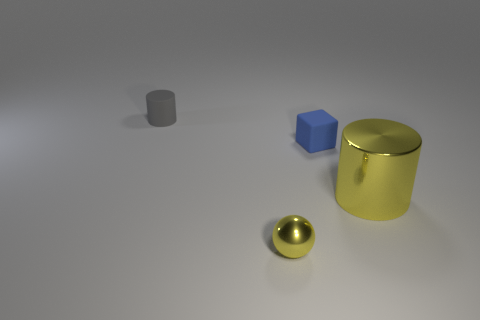How many things are either rubber things or rubber objects that are behind the tiny matte block?
Give a very brief answer. 2. There is a matte thing to the left of the block; is its shape the same as the metallic object behind the sphere?
Make the answer very short. Yes. Are there any other things that are the same color as the tiny shiny sphere?
Offer a terse response. Yes. What shape is the tiny blue thing that is made of the same material as the tiny gray cylinder?
Provide a succinct answer. Cube. What is the thing that is both to the left of the large yellow cylinder and in front of the small blue cube made of?
Keep it short and to the point. Metal. Is there any other thing that is the same size as the gray cylinder?
Provide a succinct answer. Yes. Is the small cylinder the same color as the small block?
Make the answer very short. No. The small object that is the same color as the metal cylinder is what shape?
Offer a terse response. Sphere. What number of small metallic things have the same shape as the large thing?
Provide a succinct answer. 0. There is a sphere that is the same material as the big cylinder; what is its size?
Offer a terse response. Small. 